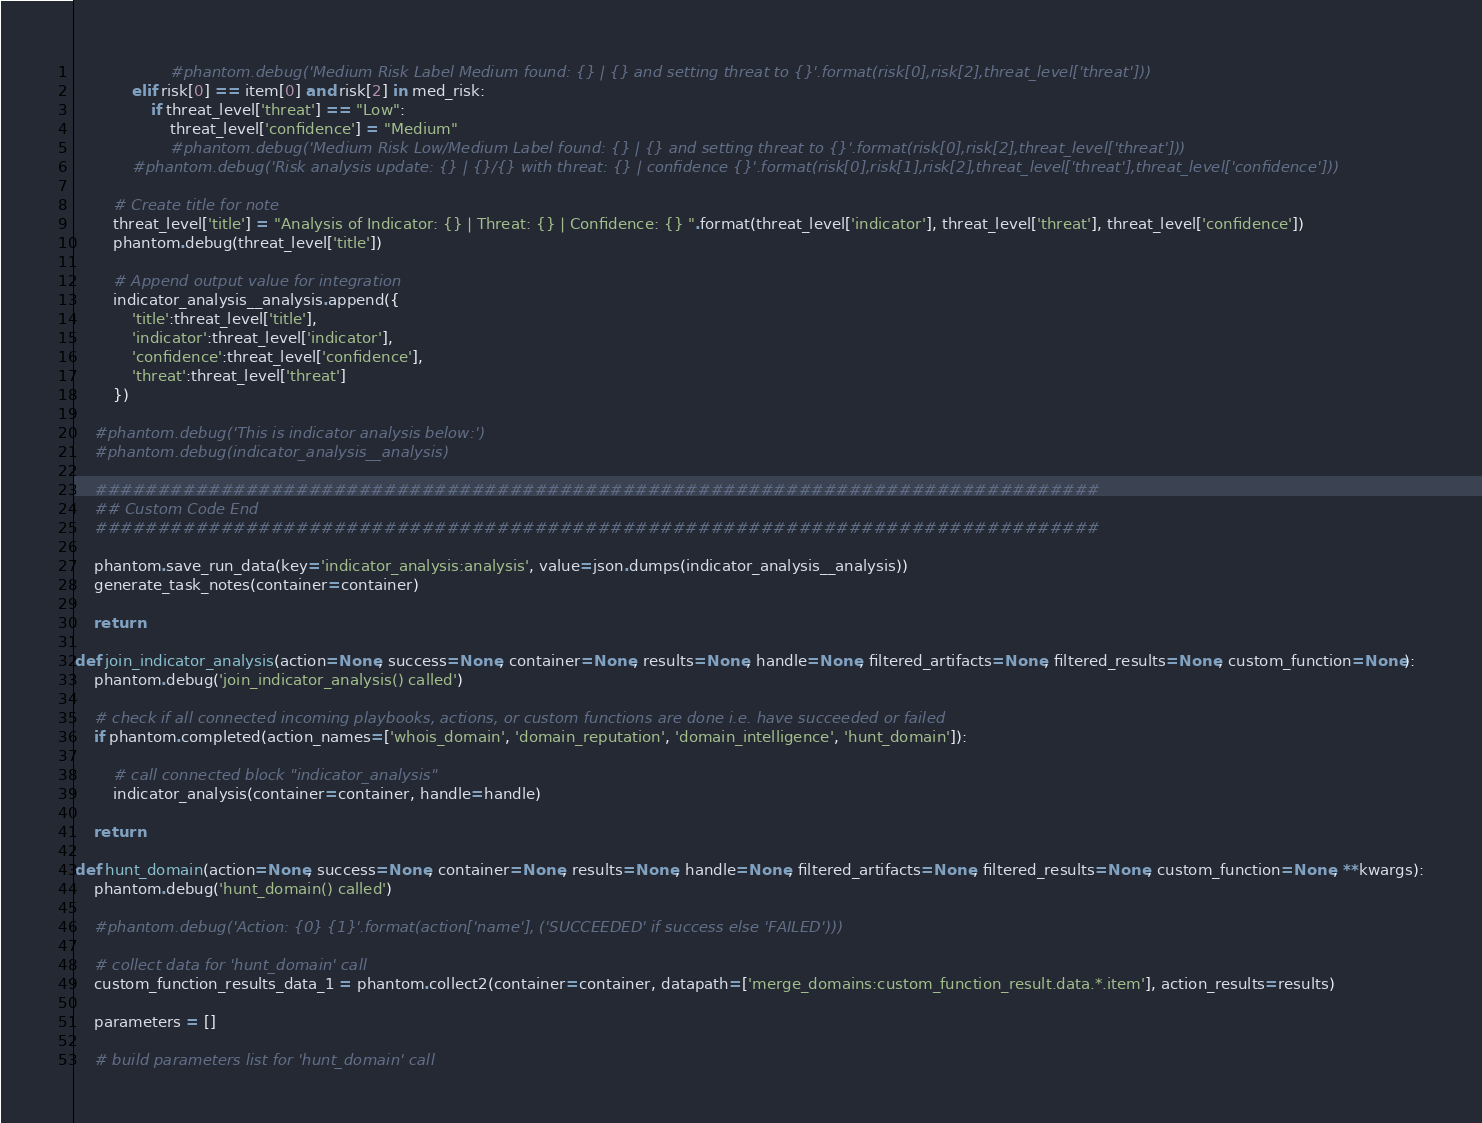<code> <loc_0><loc_0><loc_500><loc_500><_Python_>                    #phantom.debug('Medium Risk Label Medium found: {} | {} and setting threat to {}'.format(risk[0],risk[2],threat_level['threat']))
            elif risk[0] == item[0] and risk[2] in med_risk:
                if threat_level['threat'] == "Low":
                    threat_level['confidence'] = "Medium"
                    #phantom.debug('Medium Risk Low/Medium Label found: {} | {} and setting threat to {}'.format(risk[0],risk[2],threat_level['threat']))
            #phantom.debug('Risk analysis update: {} | {}/{} with threat: {} | confidence {}'.format(risk[0],risk[1],risk[2],threat_level['threat'],threat_level['confidence']))

        # Create title for note
        threat_level['title'] = "Analysis of Indicator: {} | Threat: {} | Confidence: {} ".format(threat_level['indicator'], threat_level['threat'], threat_level['confidence'])
        phantom.debug(threat_level['title'])
        
        # Append output value for integration
        indicator_analysis__analysis.append({
            'title':threat_level['title'],
            'indicator':threat_level['indicator'],
            'confidence':threat_level['confidence'],
            'threat':threat_level['threat']
        })

    #phantom.debug('This is indicator analysis below:')
    #phantom.debug(indicator_analysis__analysis)

    ################################################################################
    ## Custom Code End
    ################################################################################

    phantom.save_run_data(key='indicator_analysis:analysis', value=json.dumps(indicator_analysis__analysis))
    generate_task_notes(container=container)

    return

def join_indicator_analysis(action=None, success=None, container=None, results=None, handle=None, filtered_artifacts=None, filtered_results=None, custom_function=None):
    phantom.debug('join_indicator_analysis() called')

    # check if all connected incoming playbooks, actions, or custom functions are done i.e. have succeeded or failed
    if phantom.completed(action_names=['whois_domain', 'domain_reputation', 'domain_intelligence', 'hunt_domain']):
        
        # call connected block "indicator_analysis"
        indicator_analysis(container=container, handle=handle)
    
    return

def hunt_domain(action=None, success=None, container=None, results=None, handle=None, filtered_artifacts=None, filtered_results=None, custom_function=None, **kwargs):
    phantom.debug('hunt_domain() called')
        
    #phantom.debug('Action: {0} {1}'.format(action['name'], ('SUCCEEDED' if success else 'FAILED')))
    
    # collect data for 'hunt_domain' call
    custom_function_results_data_1 = phantom.collect2(container=container, datapath=['merge_domains:custom_function_result.data.*.item'], action_results=results)

    parameters = []
    
    # build parameters list for 'hunt_domain' call</code> 